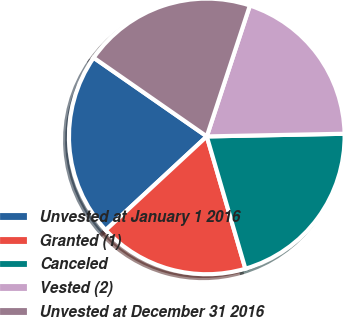Convert chart to OTSL. <chart><loc_0><loc_0><loc_500><loc_500><pie_chart><fcel>Unvested at January 1 2016<fcel>Granted (1)<fcel>Canceled<fcel>Vested (2)<fcel>Unvested at December 31 2016<nl><fcel>21.57%<fcel>17.62%<fcel>20.79%<fcel>19.63%<fcel>20.39%<nl></chart> 